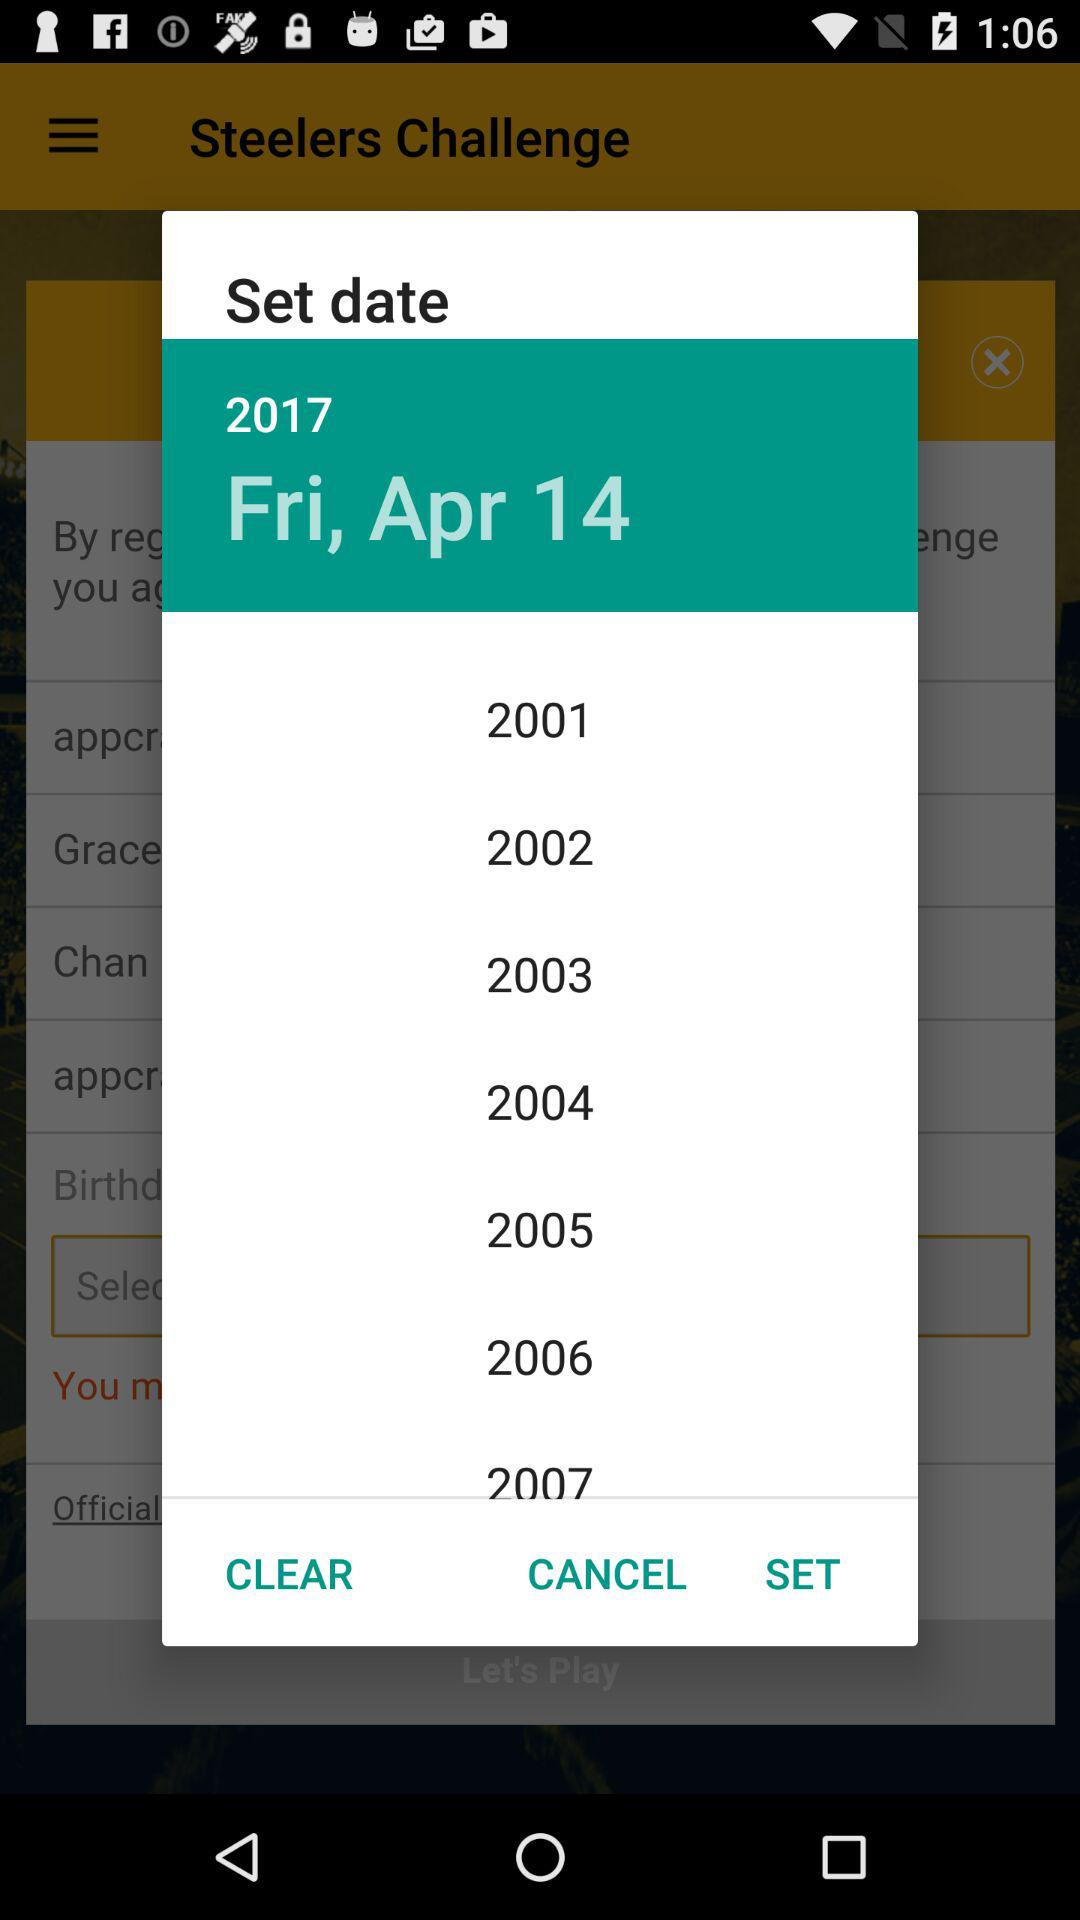How many years are available to select?
Answer the question using a single word or phrase. 7 